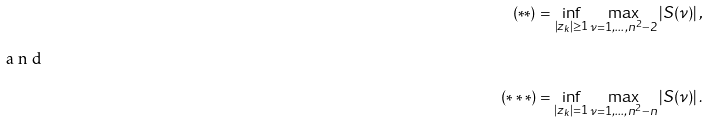Convert formula to latex. <formula><loc_0><loc_0><loc_500><loc_500>( * * ) = \inf _ { | z _ { k } | \geq 1 } \max _ { \nu = 1 , \dots , n ^ { 2 } - 2 } \left | S ( \nu ) \right | , \\ \intertext { a n d } ( * * * ) = \inf _ { | z _ { k } | = 1 } \max _ { \nu = 1 , \dots , n ^ { 2 } - n } \left | S ( \nu ) \right | .</formula> 